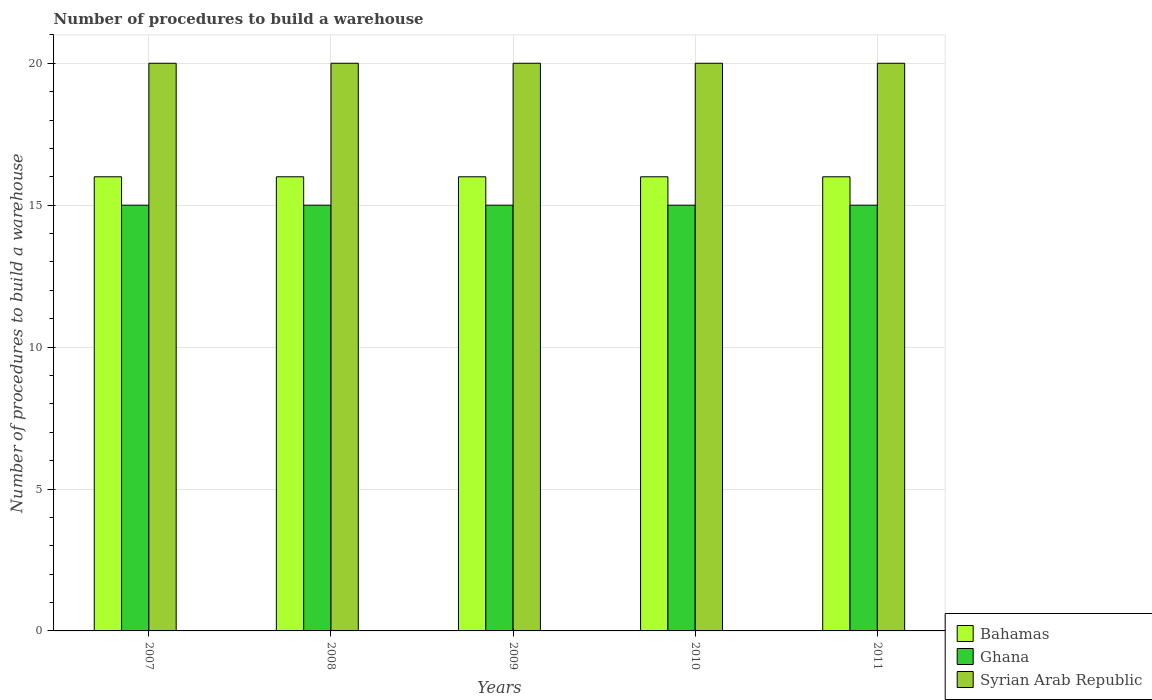How many different coloured bars are there?
Ensure brevity in your answer.  3. How many groups of bars are there?
Offer a terse response. 5. Are the number of bars per tick equal to the number of legend labels?
Your response must be concise. Yes. How many bars are there on the 5th tick from the left?
Provide a short and direct response. 3. How many bars are there on the 1st tick from the right?
Give a very brief answer. 3. In how many cases, is the number of bars for a given year not equal to the number of legend labels?
Your answer should be very brief. 0. What is the number of procedures to build a warehouse in in Ghana in 2011?
Provide a succinct answer. 15. Across all years, what is the maximum number of procedures to build a warehouse in in Syrian Arab Republic?
Your answer should be compact. 20. Across all years, what is the minimum number of procedures to build a warehouse in in Syrian Arab Republic?
Provide a succinct answer. 20. In which year was the number of procedures to build a warehouse in in Ghana maximum?
Give a very brief answer. 2007. What is the difference between the number of procedures to build a warehouse in in Bahamas in 2007 and that in 2008?
Your answer should be very brief. 0. In how many years, is the number of procedures to build a warehouse in in Syrian Arab Republic greater than 15?
Provide a succinct answer. 5. What is the ratio of the number of procedures to build a warehouse in in Syrian Arab Republic in 2007 to that in 2009?
Give a very brief answer. 1. Is the difference between the number of procedures to build a warehouse in in Ghana in 2009 and 2011 greater than the difference between the number of procedures to build a warehouse in in Bahamas in 2009 and 2011?
Provide a succinct answer. No. What is the difference between the highest and the lowest number of procedures to build a warehouse in in Ghana?
Provide a succinct answer. 0. What does the 1st bar from the left in 2007 represents?
Your answer should be very brief. Bahamas. What does the 3rd bar from the right in 2011 represents?
Your response must be concise. Bahamas. How many years are there in the graph?
Provide a short and direct response. 5. What is the difference between two consecutive major ticks on the Y-axis?
Ensure brevity in your answer.  5. Are the values on the major ticks of Y-axis written in scientific E-notation?
Keep it short and to the point. No. Does the graph contain grids?
Offer a very short reply. Yes. Where does the legend appear in the graph?
Your answer should be compact. Bottom right. How many legend labels are there?
Ensure brevity in your answer.  3. How are the legend labels stacked?
Keep it short and to the point. Vertical. What is the title of the graph?
Ensure brevity in your answer.  Number of procedures to build a warehouse. What is the label or title of the X-axis?
Ensure brevity in your answer.  Years. What is the label or title of the Y-axis?
Ensure brevity in your answer.  Number of procedures to build a warehouse. What is the Number of procedures to build a warehouse in Syrian Arab Republic in 2007?
Offer a terse response. 20. What is the Number of procedures to build a warehouse of Bahamas in 2008?
Give a very brief answer. 16. What is the Number of procedures to build a warehouse of Syrian Arab Republic in 2009?
Your answer should be compact. 20. What is the Number of procedures to build a warehouse of Bahamas in 2010?
Your response must be concise. 16. What is the Number of procedures to build a warehouse in Ghana in 2010?
Ensure brevity in your answer.  15. What is the Number of procedures to build a warehouse of Syrian Arab Republic in 2011?
Offer a very short reply. 20. Across all years, what is the maximum Number of procedures to build a warehouse in Bahamas?
Your response must be concise. 16. Across all years, what is the maximum Number of procedures to build a warehouse of Ghana?
Give a very brief answer. 15. Across all years, what is the maximum Number of procedures to build a warehouse of Syrian Arab Republic?
Make the answer very short. 20. Across all years, what is the minimum Number of procedures to build a warehouse in Bahamas?
Keep it short and to the point. 16. Across all years, what is the minimum Number of procedures to build a warehouse in Syrian Arab Republic?
Your response must be concise. 20. What is the total Number of procedures to build a warehouse of Bahamas in the graph?
Offer a very short reply. 80. What is the difference between the Number of procedures to build a warehouse of Bahamas in 2007 and that in 2008?
Offer a terse response. 0. What is the difference between the Number of procedures to build a warehouse of Syrian Arab Republic in 2007 and that in 2008?
Keep it short and to the point. 0. What is the difference between the Number of procedures to build a warehouse of Bahamas in 2007 and that in 2009?
Make the answer very short. 0. What is the difference between the Number of procedures to build a warehouse of Syrian Arab Republic in 2007 and that in 2009?
Offer a very short reply. 0. What is the difference between the Number of procedures to build a warehouse in Syrian Arab Republic in 2007 and that in 2010?
Offer a very short reply. 0. What is the difference between the Number of procedures to build a warehouse of Bahamas in 2007 and that in 2011?
Your response must be concise. 0. What is the difference between the Number of procedures to build a warehouse of Ghana in 2007 and that in 2011?
Ensure brevity in your answer.  0. What is the difference between the Number of procedures to build a warehouse in Bahamas in 2008 and that in 2009?
Your answer should be very brief. 0. What is the difference between the Number of procedures to build a warehouse of Bahamas in 2008 and that in 2010?
Keep it short and to the point. 0. What is the difference between the Number of procedures to build a warehouse in Bahamas in 2008 and that in 2011?
Your response must be concise. 0. What is the difference between the Number of procedures to build a warehouse in Ghana in 2009 and that in 2010?
Make the answer very short. 0. What is the difference between the Number of procedures to build a warehouse of Syrian Arab Republic in 2009 and that in 2010?
Your answer should be compact. 0. What is the difference between the Number of procedures to build a warehouse in Bahamas in 2009 and that in 2011?
Your answer should be compact. 0. What is the difference between the Number of procedures to build a warehouse in Syrian Arab Republic in 2010 and that in 2011?
Give a very brief answer. 0. What is the difference between the Number of procedures to build a warehouse in Bahamas in 2007 and the Number of procedures to build a warehouse in Ghana in 2008?
Keep it short and to the point. 1. What is the difference between the Number of procedures to build a warehouse in Ghana in 2007 and the Number of procedures to build a warehouse in Syrian Arab Republic in 2008?
Make the answer very short. -5. What is the difference between the Number of procedures to build a warehouse in Bahamas in 2007 and the Number of procedures to build a warehouse in Ghana in 2009?
Give a very brief answer. 1. What is the difference between the Number of procedures to build a warehouse of Ghana in 2007 and the Number of procedures to build a warehouse of Syrian Arab Republic in 2009?
Provide a succinct answer. -5. What is the difference between the Number of procedures to build a warehouse in Bahamas in 2007 and the Number of procedures to build a warehouse in Ghana in 2011?
Keep it short and to the point. 1. What is the difference between the Number of procedures to build a warehouse in Bahamas in 2007 and the Number of procedures to build a warehouse in Syrian Arab Republic in 2011?
Provide a short and direct response. -4. What is the difference between the Number of procedures to build a warehouse of Ghana in 2008 and the Number of procedures to build a warehouse of Syrian Arab Republic in 2009?
Offer a very short reply. -5. What is the difference between the Number of procedures to build a warehouse of Ghana in 2008 and the Number of procedures to build a warehouse of Syrian Arab Republic in 2010?
Your response must be concise. -5. What is the difference between the Number of procedures to build a warehouse in Bahamas in 2008 and the Number of procedures to build a warehouse in Ghana in 2011?
Your answer should be very brief. 1. What is the difference between the Number of procedures to build a warehouse in Ghana in 2008 and the Number of procedures to build a warehouse in Syrian Arab Republic in 2011?
Ensure brevity in your answer.  -5. What is the difference between the Number of procedures to build a warehouse of Bahamas in 2009 and the Number of procedures to build a warehouse of Syrian Arab Republic in 2010?
Provide a succinct answer. -4. What is the difference between the Number of procedures to build a warehouse of Ghana in 2009 and the Number of procedures to build a warehouse of Syrian Arab Republic in 2010?
Give a very brief answer. -5. What is the difference between the Number of procedures to build a warehouse in Bahamas in 2009 and the Number of procedures to build a warehouse in Syrian Arab Republic in 2011?
Ensure brevity in your answer.  -4. What is the difference between the Number of procedures to build a warehouse of Bahamas in 2010 and the Number of procedures to build a warehouse of Ghana in 2011?
Your response must be concise. 1. What is the difference between the Number of procedures to build a warehouse of Bahamas in 2010 and the Number of procedures to build a warehouse of Syrian Arab Republic in 2011?
Offer a terse response. -4. What is the average Number of procedures to build a warehouse in Bahamas per year?
Offer a very short reply. 16. What is the average Number of procedures to build a warehouse of Ghana per year?
Keep it short and to the point. 15. What is the average Number of procedures to build a warehouse of Syrian Arab Republic per year?
Make the answer very short. 20. In the year 2007, what is the difference between the Number of procedures to build a warehouse of Ghana and Number of procedures to build a warehouse of Syrian Arab Republic?
Your answer should be very brief. -5. In the year 2008, what is the difference between the Number of procedures to build a warehouse of Ghana and Number of procedures to build a warehouse of Syrian Arab Republic?
Ensure brevity in your answer.  -5. In the year 2009, what is the difference between the Number of procedures to build a warehouse in Bahamas and Number of procedures to build a warehouse in Ghana?
Provide a succinct answer. 1. In the year 2009, what is the difference between the Number of procedures to build a warehouse in Bahamas and Number of procedures to build a warehouse in Syrian Arab Republic?
Ensure brevity in your answer.  -4. In the year 2010, what is the difference between the Number of procedures to build a warehouse of Bahamas and Number of procedures to build a warehouse of Ghana?
Keep it short and to the point. 1. In the year 2010, what is the difference between the Number of procedures to build a warehouse of Bahamas and Number of procedures to build a warehouse of Syrian Arab Republic?
Your response must be concise. -4. In the year 2010, what is the difference between the Number of procedures to build a warehouse of Ghana and Number of procedures to build a warehouse of Syrian Arab Republic?
Make the answer very short. -5. What is the ratio of the Number of procedures to build a warehouse in Bahamas in 2007 to that in 2008?
Offer a very short reply. 1. What is the ratio of the Number of procedures to build a warehouse in Syrian Arab Republic in 2007 to that in 2008?
Ensure brevity in your answer.  1. What is the ratio of the Number of procedures to build a warehouse of Ghana in 2007 to that in 2009?
Provide a short and direct response. 1. What is the ratio of the Number of procedures to build a warehouse of Syrian Arab Republic in 2007 to that in 2009?
Provide a succinct answer. 1. What is the ratio of the Number of procedures to build a warehouse in Ghana in 2007 to that in 2010?
Offer a terse response. 1. What is the ratio of the Number of procedures to build a warehouse of Syrian Arab Republic in 2007 to that in 2010?
Keep it short and to the point. 1. What is the ratio of the Number of procedures to build a warehouse of Bahamas in 2007 to that in 2011?
Keep it short and to the point. 1. What is the ratio of the Number of procedures to build a warehouse of Ghana in 2007 to that in 2011?
Ensure brevity in your answer.  1. What is the ratio of the Number of procedures to build a warehouse in Syrian Arab Republic in 2007 to that in 2011?
Your response must be concise. 1. What is the ratio of the Number of procedures to build a warehouse of Ghana in 2008 to that in 2009?
Give a very brief answer. 1. What is the ratio of the Number of procedures to build a warehouse of Syrian Arab Republic in 2008 to that in 2009?
Offer a very short reply. 1. What is the ratio of the Number of procedures to build a warehouse in Ghana in 2008 to that in 2010?
Offer a terse response. 1. What is the ratio of the Number of procedures to build a warehouse of Syrian Arab Republic in 2008 to that in 2011?
Keep it short and to the point. 1. What is the ratio of the Number of procedures to build a warehouse of Bahamas in 2009 to that in 2011?
Make the answer very short. 1. What is the ratio of the Number of procedures to build a warehouse of Bahamas in 2010 to that in 2011?
Your answer should be very brief. 1. What is the difference between the highest and the lowest Number of procedures to build a warehouse in Bahamas?
Provide a short and direct response. 0. What is the difference between the highest and the lowest Number of procedures to build a warehouse of Ghana?
Ensure brevity in your answer.  0. 